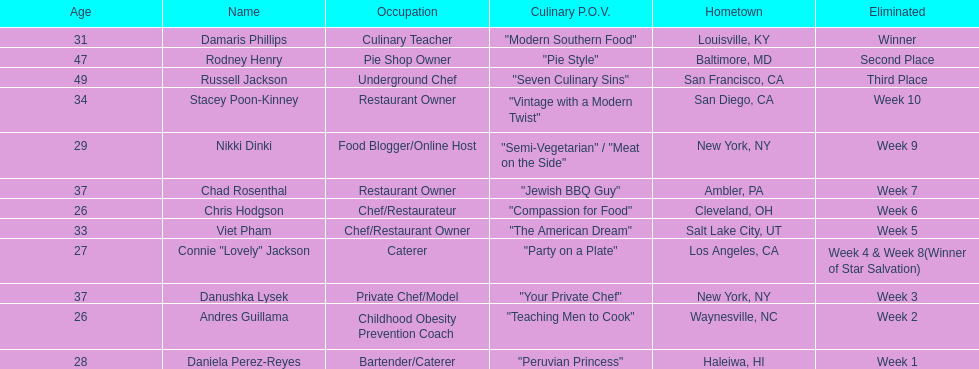Who was the top chef? Damaris Phillips. 